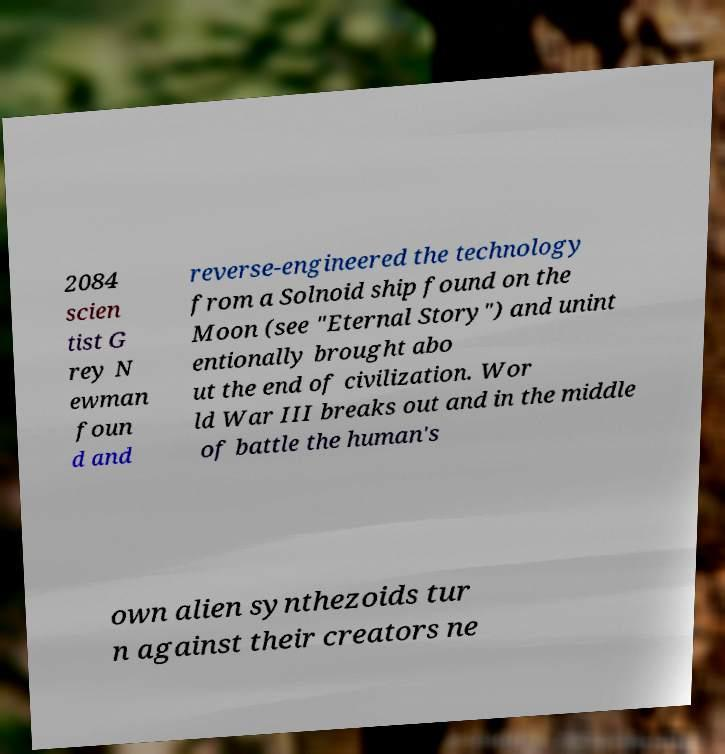Can you read and provide the text displayed in the image?This photo seems to have some interesting text. Can you extract and type it out for me? 2084 scien tist G rey N ewman foun d and reverse-engineered the technology from a Solnoid ship found on the Moon (see "Eternal Story") and unint entionally brought abo ut the end of civilization. Wor ld War III breaks out and in the middle of battle the human's own alien synthezoids tur n against their creators ne 